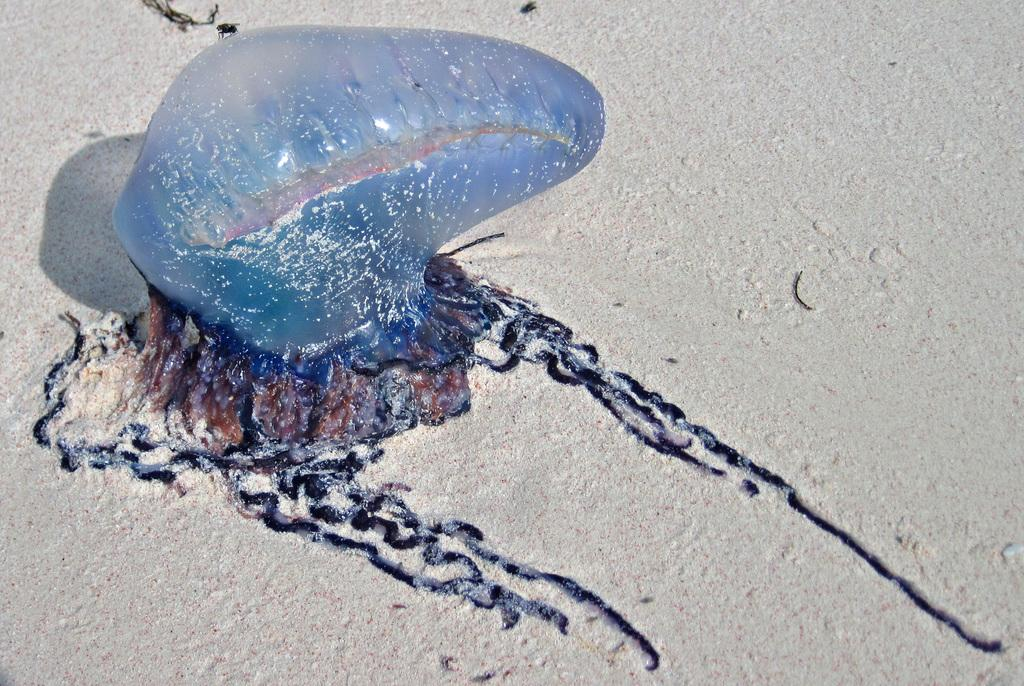What is the main subject of the image? The main subject of the image is an object on the road. When was the image taken? The image was taken during the day. Can you describe the setting of the image? The image is of a scene on the road. What type of songs can be heard playing in the background of the image? There is no audio or background music present in the image, so it is not possible to determine what songs might be heard. 